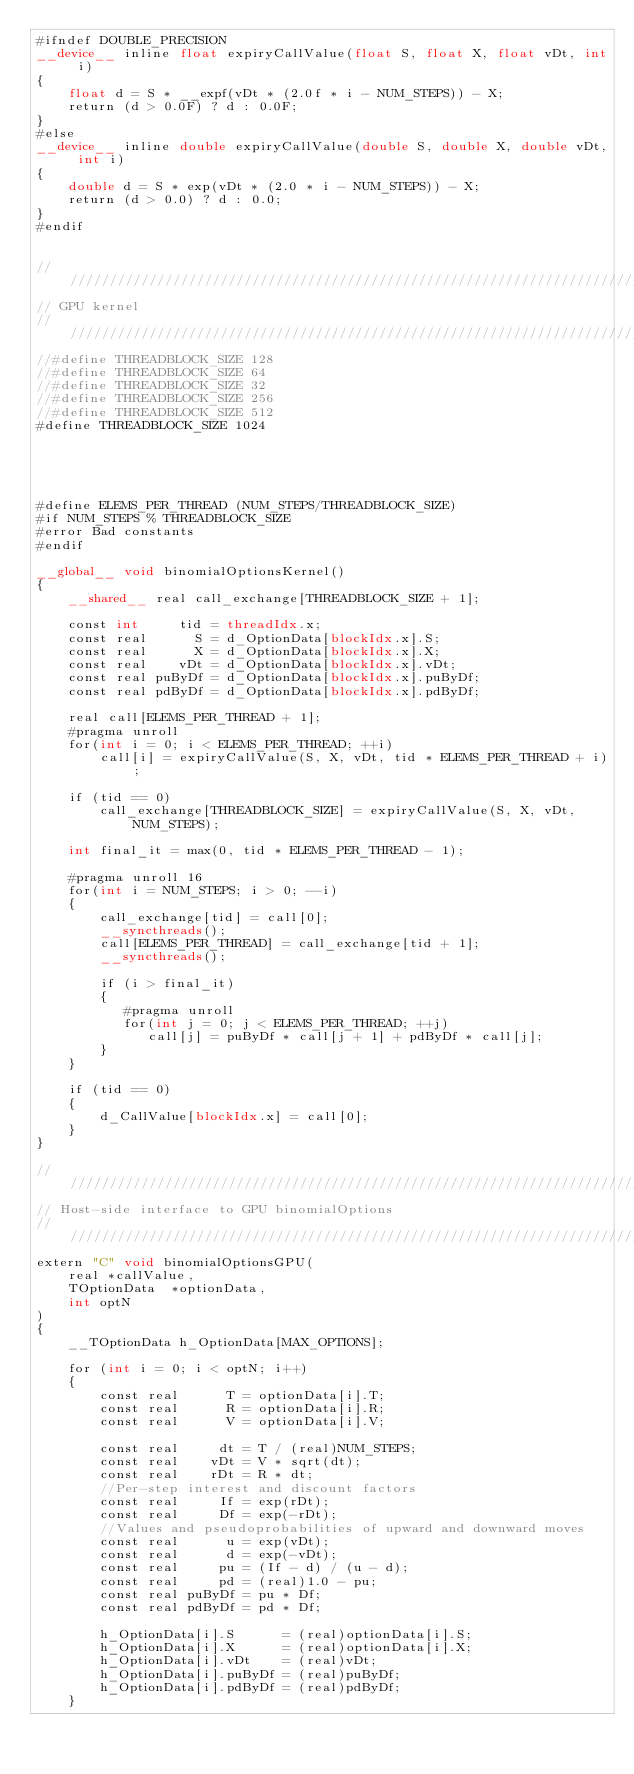<code> <loc_0><loc_0><loc_500><loc_500><_Cuda_>#ifndef DOUBLE_PRECISION
__device__ inline float expiryCallValue(float S, float X, float vDt, int i)
{
    float d = S * __expf(vDt * (2.0f * i - NUM_STEPS)) - X;
    return (d > 0.0F) ? d : 0.0F;
}
#else
__device__ inline double expiryCallValue(double S, double X, double vDt, int i)
{
    double d = S * exp(vDt * (2.0 * i - NUM_STEPS)) - X;
    return (d > 0.0) ? d : 0.0;
}
#endif


////////////////////////////////////////////////////////////////////////////////
// GPU kernel
////////////////////////////////////////////////////////////////////////////////
//#define THREADBLOCK_SIZE 128
//#define THREADBLOCK_SIZE 64 
//#define THREADBLOCK_SIZE 32 
//#define THREADBLOCK_SIZE 256 
//#define THREADBLOCK_SIZE 512 
#define THREADBLOCK_SIZE 1024 





#define ELEMS_PER_THREAD (NUM_STEPS/THREADBLOCK_SIZE)
#if NUM_STEPS % THREADBLOCK_SIZE
#error Bad constants
#endif

__global__ void binomialOptionsKernel()
{
    __shared__ real call_exchange[THREADBLOCK_SIZE + 1];

    const int     tid = threadIdx.x;
    const real      S = d_OptionData[blockIdx.x].S;
    const real      X = d_OptionData[blockIdx.x].X;
    const real    vDt = d_OptionData[blockIdx.x].vDt;
    const real puByDf = d_OptionData[blockIdx.x].puByDf;
    const real pdByDf = d_OptionData[blockIdx.x].pdByDf;

    real call[ELEMS_PER_THREAD + 1];
    #pragma unroll
    for(int i = 0; i < ELEMS_PER_THREAD; ++i)
        call[i] = expiryCallValue(S, X, vDt, tid * ELEMS_PER_THREAD + i);

    if (tid == 0)
        call_exchange[THREADBLOCK_SIZE] = expiryCallValue(S, X, vDt, NUM_STEPS);

    int final_it = max(0, tid * ELEMS_PER_THREAD - 1);

    #pragma unroll 16
    for(int i = NUM_STEPS; i > 0; --i)
    {
        call_exchange[tid] = call[0];
        __syncthreads();
        call[ELEMS_PER_THREAD] = call_exchange[tid + 1];
        __syncthreads();

        if (i > final_it)
        {
           #pragma unroll
           for(int j = 0; j < ELEMS_PER_THREAD; ++j)
              call[j] = puByDf * call[j + 1] + pdByDf * call[j];
        }
    }

    if (tid == 0)
    {
        d_CallValue[blockIdx.x] = call[0];
    }
}

////////////////////////////////////////////////////////////////////////////////
// Host-side interface to GPU binomialOptions
////////////////////////////////////////////////////////////////////////////////
extern "C" void binomialOptionsGPU(
    real *callValue,
    TOptionData  *optionData,
    int optN
)
{
    __TOptionData h_OptionData[MAX_OPTIONS];

    for (int i = 0; i < optN; i++)
    {
        const real      T = optionData[i].T;
        const real      R = optionData[i].R;
        const real      V = optionData[i].V;

        const real     dt = T / (real)NUM_STEPS;
        const real    vDt = V * sqrt(dt);
        const real    rDt = R * dt;
        //Per-step interest and discount factors
        const real     If = exp(rDt);
        const real     Df = exp(-rDt);
        //Values and pseudoprobabilities of upward and downward moves
        const real      u = exp(vDt);
        const real      d = exp(-vDt);
        const real     pu = (If - d) / (u - d);
        const real     pd = (real)1.0 - pu;
        const real puByDf = pu * Df;
        const real pdByDf = pd * Df;

        h_OptionData[i].S      = (real)optionData[i].S;
        h_OptionData[i].X      = (real)optionData[i].X;
        h_OptionData[i].vDt    = (real)vDt;
        h_OptionData[i].puByDf = (real)puByDf;
        h_OptionData[i].pdByDf = (real)pdByDf;
    }
</code> 